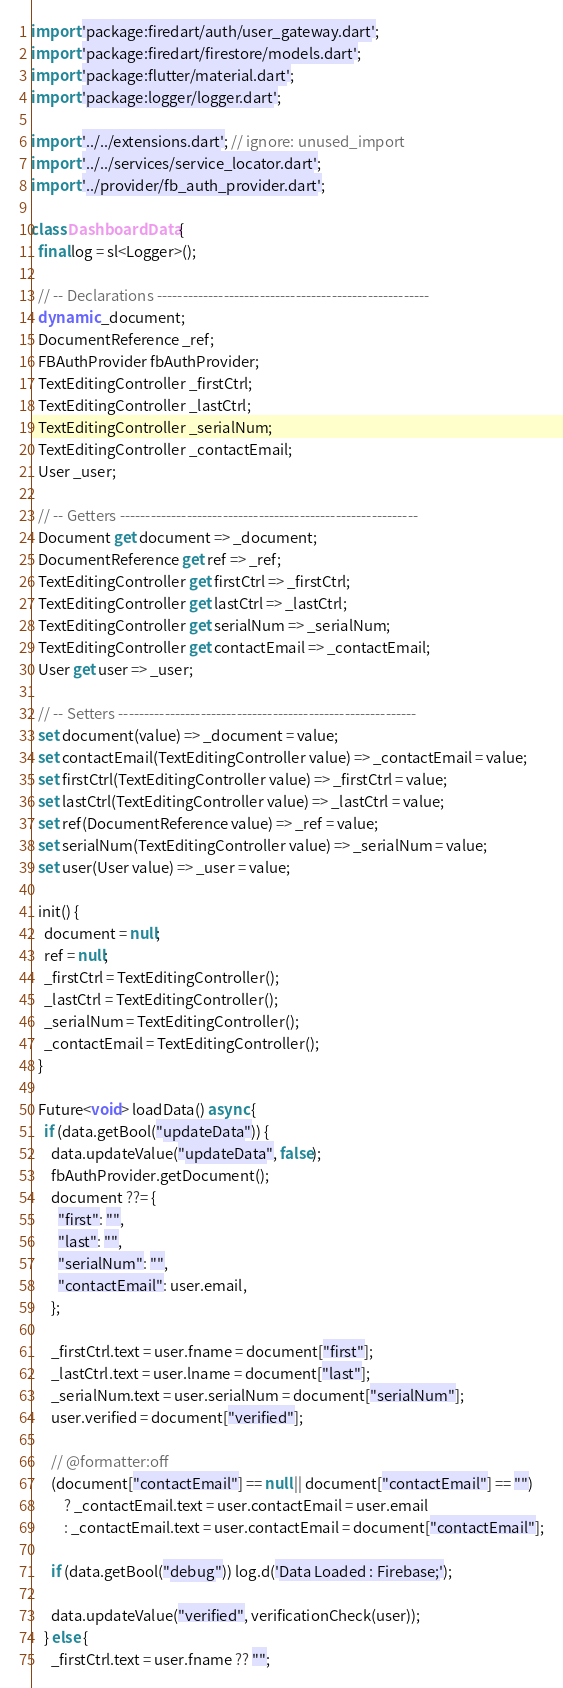<code> <loc_0><loc_0><loc_500><loc_500><_Dart_>import 'package:firedart/auth/user_gateway.dart';
import 'package:firedart/firestore/models.dart';
import 'package:flutter/material.dart';
import 'package:logger/logger.dart';

import '../../extensions.dart'; // ignore: unused_import
import '../../services/service_locator.dart';
import '../provider/fb_auth_provider.dart';

class DashboardData {
  final log = sl<Logger>();

  // -- Declarations -----------------------------------------------------
  dynamic _document;
  DocumentReference _ref;
  FBAuthProvider fbAuthProvider;
  TextEditingController _firstCtrl;
  TextEditingController _lastCtrl;
  TextEditingController _serialNum;
  TextEditingController _contactEmail;
  User _user;

  // -- Getters ----------------------------------------------------------
  Document get document => _document;
  DocumentReference get ref => _ref;
  TextEditingController get firstCtrl => _firstCtrl;
  TextEditingController get lastCtrl => _lastCtrl;
  TextEditingController get serialNum => _serialNum;
  TextEditingController get contactEmail => _contactEmail;
  User get user => _user;

  // -- Setters ----------------------------------------------------------
  set document(value) => _document = value;
  set contactEmail(TextEditingController value) => _contactEmail = value;
  set firstCtrl(TextEditingController value) => _firstCtrl = value;
  set lastCtrl(TextEditingController value) => _lastCtrl = value;
  set ref(DocumentReference value) => _ref = value;
  set serialNum(TextEditingController value) => _serialNum = value;
  set user(User value) => _user = value;

  init() {
    document = null;
    ref = null;
    _firstCtrl = TextEditingController();
    _lastCtrl = TextEditingController();
    _serialNum = TextEditingController();
    _contactEmail = TextEditingController();
  }

  Future<void> loadData() async {
    if (data.getBool("updateData")) {
      data.updateValue("updateData", false);
      fbAuthProvider.getDocument();
      document ??= {
        "first": "",
        "last": "",
        "serialNum": "",
        "contactEmail": user.email,
      };

      _firstCtrl.text = user.fname = document["first"];
      _lastCtrl.text = user.lname = document["last"];
      _serialNum.text = user.serialNum = document["serialNum"];
      user.verified = document["verified"];

      // @formatter:off
      (document["contactEmail"] == null || document["contactEmail"] == "")
          ? _contactEmail.text = user.contactEmail = user.email
          : _contactEmail.text = user.contactEmail = document["contactEmail"];

      if (data.getBool("debug")) log.d('Data Loaded : Firebase;');

      data.updateValue("verified", verificationCheck(user));
    } else {
      _firstCtrl.text = user.fname ?? "";</code> 